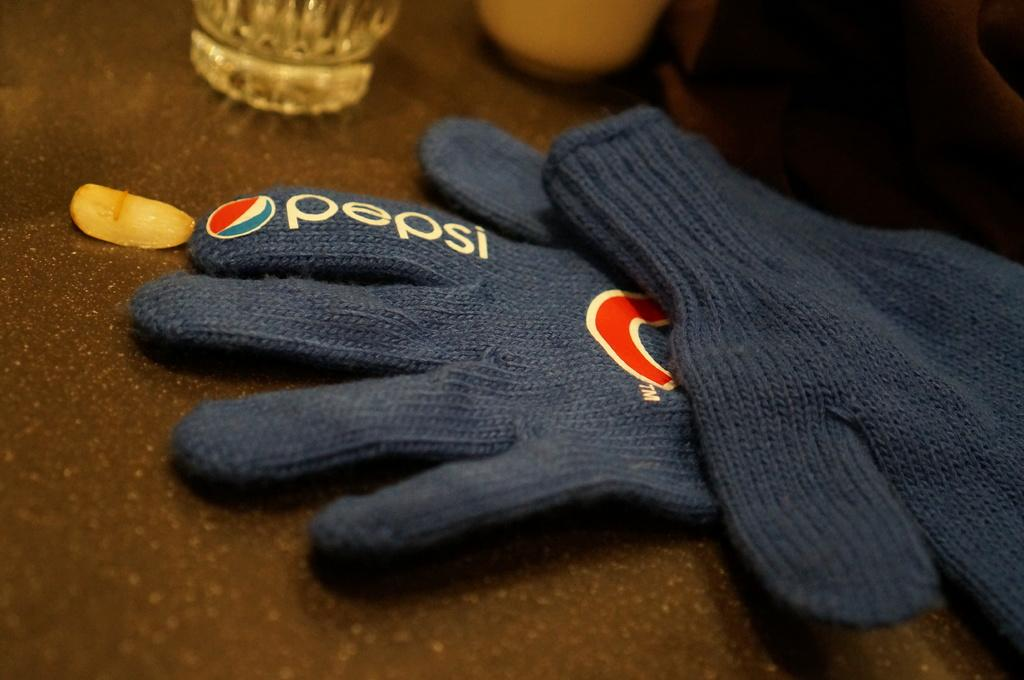What is the color of the table in the image? The table in the image is brown. What type of gloves are on the table? There are blue gloves on the table. What can be found on the table besides the gloves? There is a glass and a white object on the table. What color is the top right corner of the image? The top right corner of the image is brown in color. What type of sack is being used for a bath in the image? There is no sack or bath present in the image. What is the surprise element in the image? There is no surprise element mentioned in the provided facts, as the image only contains a brown table, blue gloves, a glass, a white object, and a brown top right corner. 